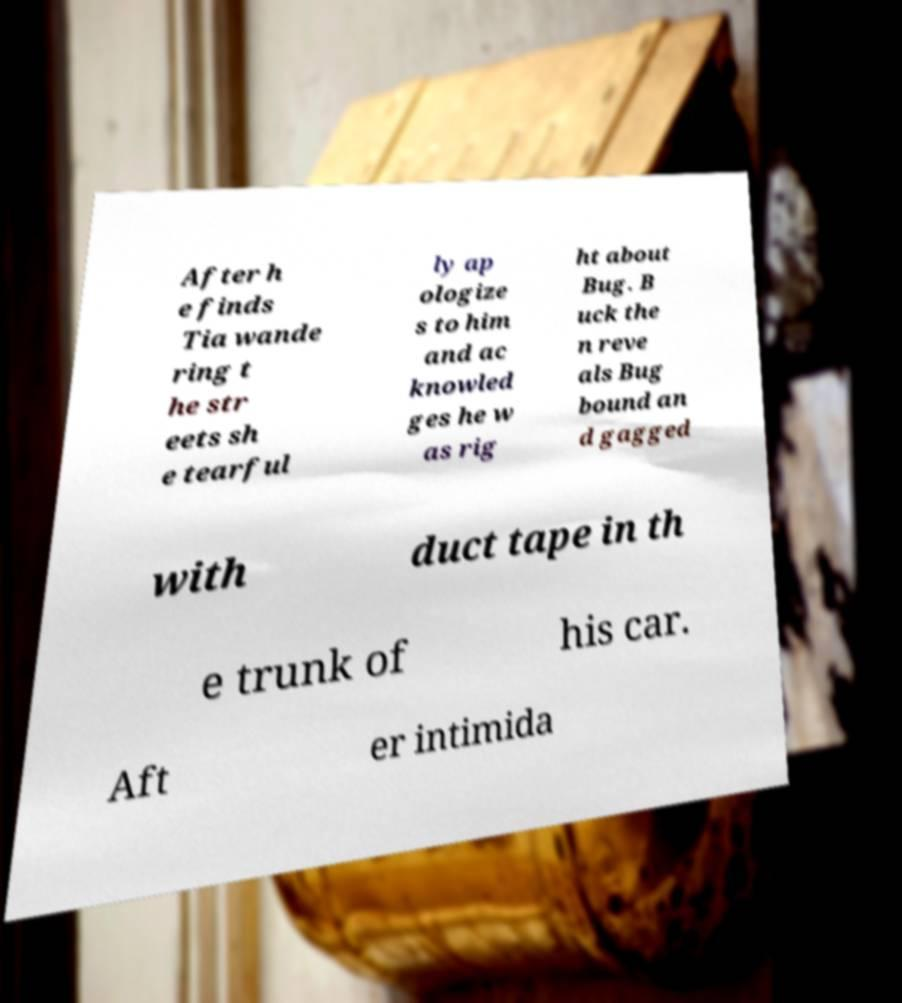Please read and relay the text visible in this image. What does it say? After h e finds Tia wande ring t he str eets sh e tearful ly ap ologize s to him and ac knowled ges he w as rig ht about Bug. B uck the n reve als Bug bound an d gagged with duct tape in th e trunk of his car. Aft er intimida 